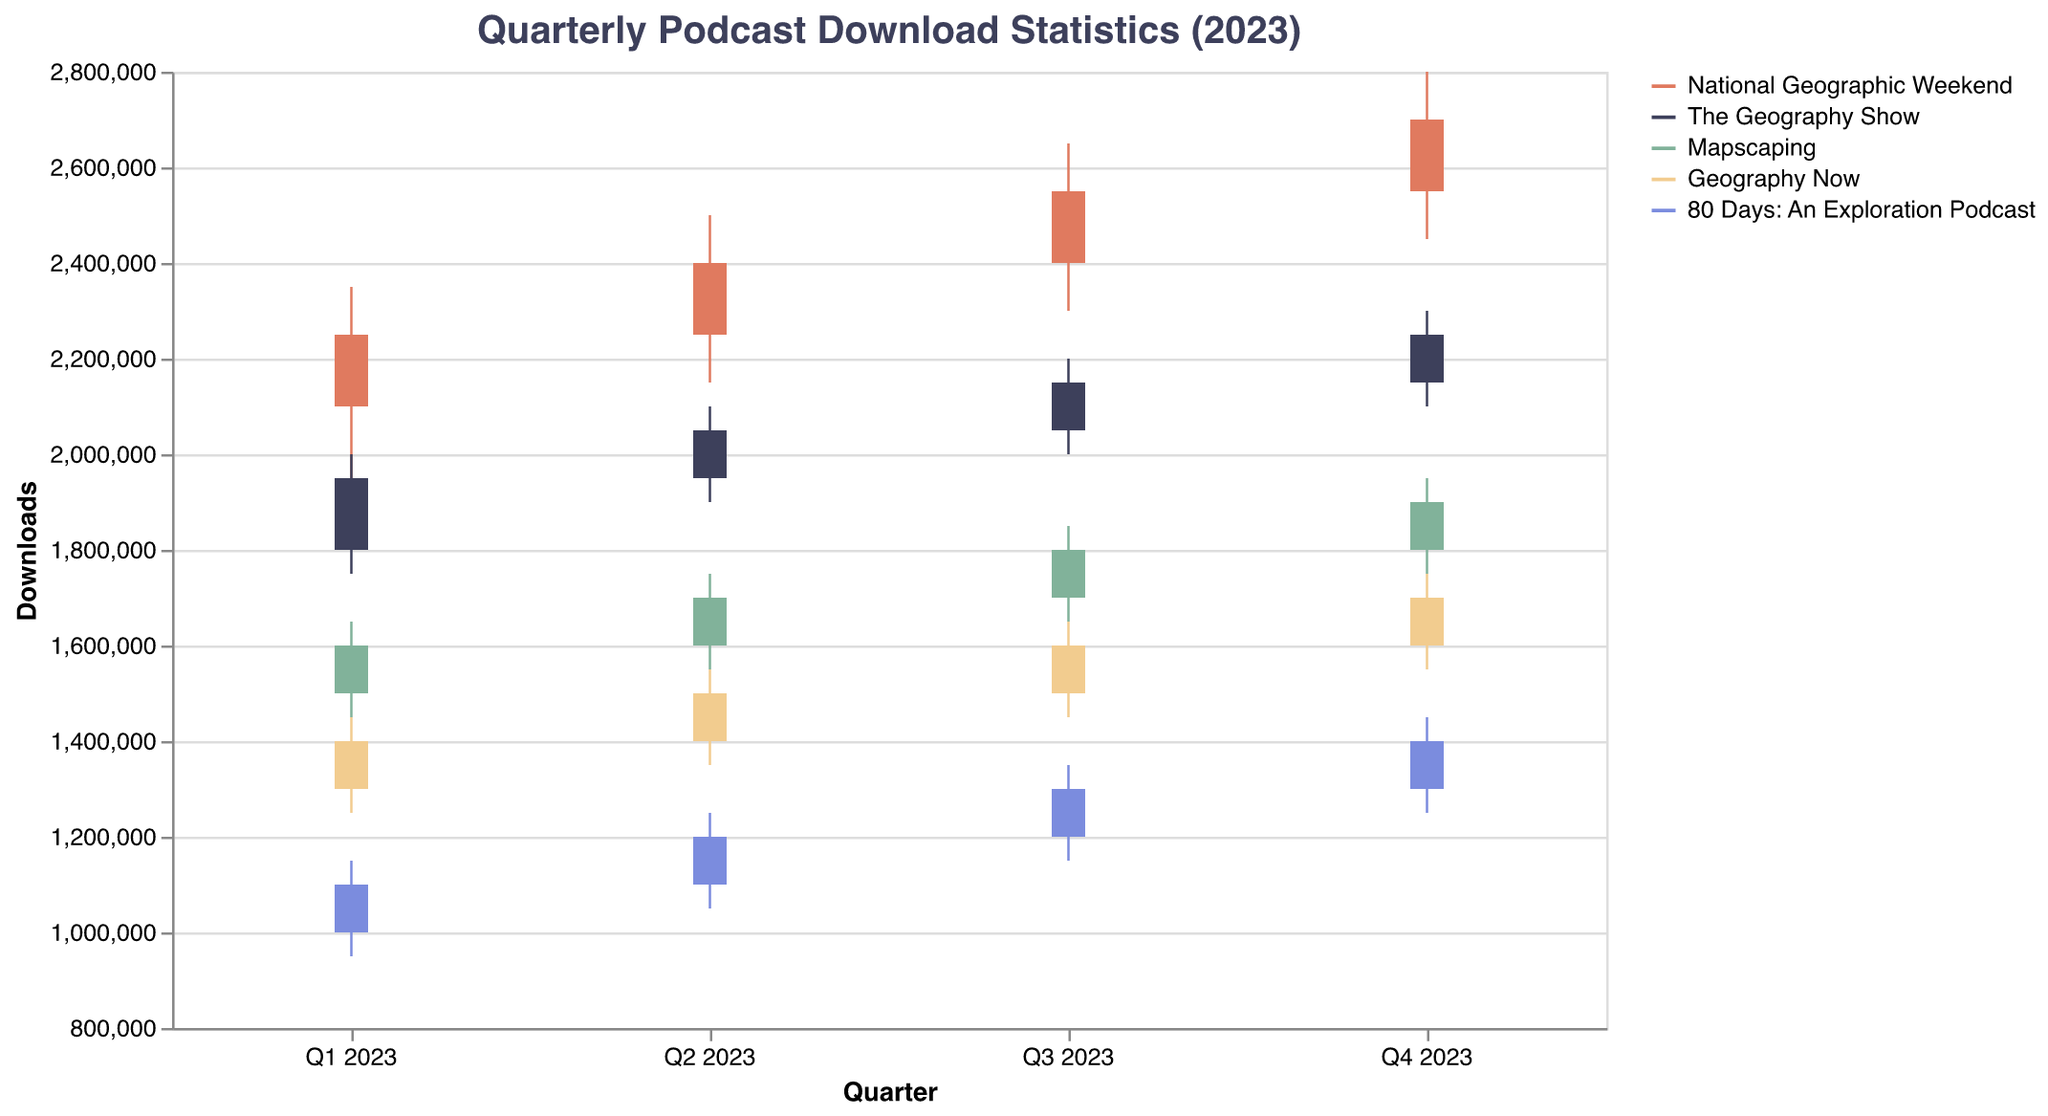What is the title of the figure? The title of the figure is located at the top and is used to summarize the data presented. The title reads "Quarterly Podcast Download Statistics (2023)."
Answer: Quarterly Podcast Download Statistics (2023) What are the colors representing each podcast? The colors representing each podcast are indicated in the legend on the right side of the chart. They are as follows: National Geographic Weekend (red), The Geography Show (dark blue), Mapscaping (light green), Geography Now (yellow), and 80 Days: An Exploration Podcast (light blue).
Answer: red, dark blue, light green, yellow, light blue Which podcast had the highest closing value in Q4 2023? To find the highest closing value in Q4 2023, look at the bar heights in the Q4 2023 column and compare the closing values. National Geographic Weekend has the highest close of 2,700,000 downloads.
Answer: National Geographic Weekend What was the opening value for The Geography Show in Q3 2023? Check the bar for The Geography Show in the Q3 2023 column. The opening value is at the bottom of the bar and it reads 2,050,000 downloads.
Answer: 2,050,000 Which podcast showed the largest increase in closing value from Q1 2023 to Q4 2023? Calculate the increase in closing value from Q1 2023 to Q4 2023 for each podcast: National Geographic Weekend (2,700,000 - 2,250,000 = 450,000), The Geography Show (2,250,000 - 1,950,000 = 300,000), Mapscaping (1,900,000 - 1,600,000 = 300,000), Geography Now (1,700,000 - 1,400,000 = 300,000), and 80 Days: An Exploration Podcast (1,400,000 - 1,100,000 = 300,000). National Geographic Weekend has the largest increase of 450,000.
Answer: National Geographic Weekend Between which quarters did National Geographic Weekend see the largest increase in closing value and how much was the increase? Compare the closing values for National Geographic Weekend between each pair of consecutive quarters: Q1 to Q2 (2,400,000 - 2,250,000 = 150,000), Q2 to Q3 (2,550,000 - 2,400,000 = 150,000), Q3 to Q4 (2,700,000 - 2,550,000 = 150,000). The increase was 150,000 for each transition.
Answer: Q1, Q2 - 150,000 Which quarter did Geography Now have the highest high value? Compare the high values for Geography Now across all quarters: Q1 (1,450,000), Q2 (1,550,000), Q3 (1,650,000), Q4 (1,750,000). Geography Now had the highest high value in Q4 2023 with 1,750,000 downloads.
Answer: Q4 2023 How many downloads were recorded at the open for 80 Days: An Exploration Podcast in Q1 2023? To find the opening value for 80 Days: An Exploration Podcast in Q1 2023, check the bar at the bottom of the Q1 2023 column for the podcast. The opening value is 1,000,000 downloads.
Answer: 1,000,000 What is the average closing value for Mapscaping across all quarters in 2023? Calculate the average closing value by adding the closing values of Mapscaping for Q1 (1,600,000), Q2 (1,700,000), Q3 (1,800,000), and Q4 (1,900,000) and then dividing by 4. (1,600,000 + 1,700,000 + 1,800,000 + 1,900,000) / 4 = 7,000,000 / 4 = 1,750,000.
Answer: 1,750,000 